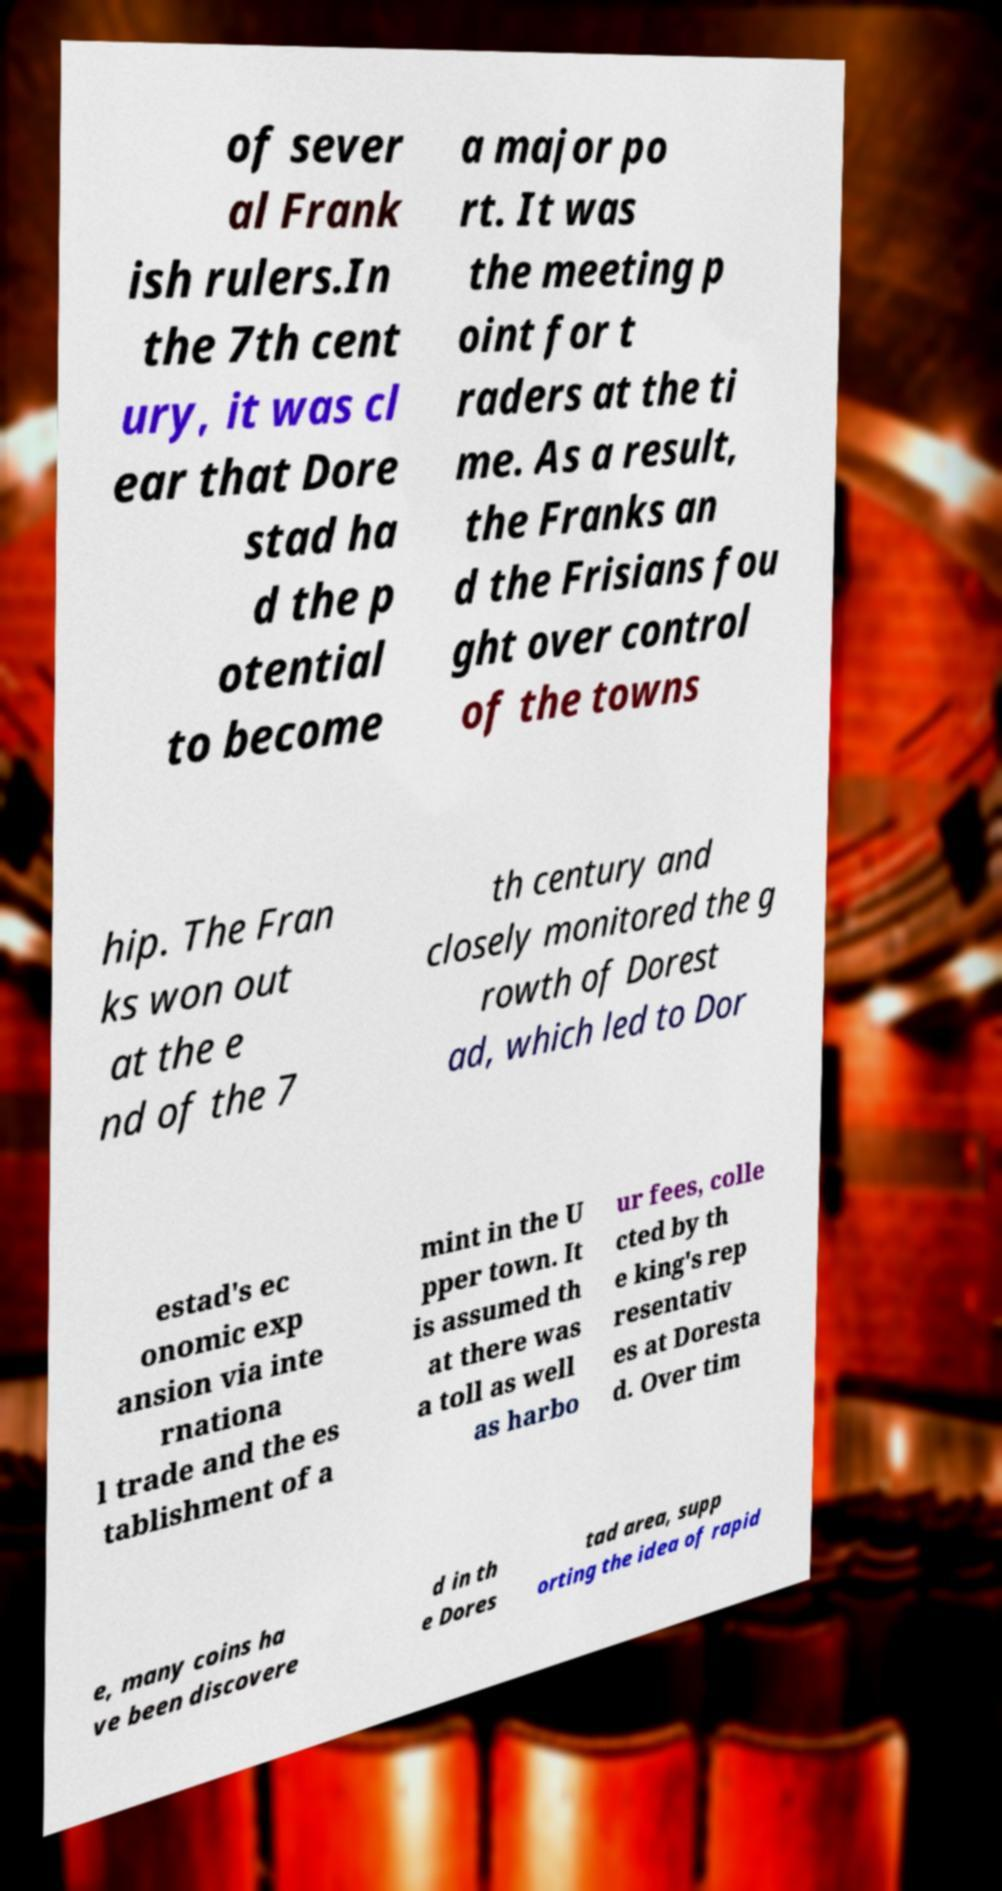Can you read and provide the text displayed in the image?This photo seems to have some interesting text. Can you extract and type it out for me? of sever al Frank ish rulers.In the 7th cent ury, it was cl ear that Dore stad ha d the p otential to become a major po rt. It was the meeting p oint for t raders at the ti me. As a result, the Franks an d the Frisians fou ght over control of the towns hip. The Fran ks won out at the e nd of the 7 th century and closely monitored the g rowth of Dorest ad, which led to Dor estad's ec onomic exp ansion via inte rnationa l trade and the es tablishment of a mint in the U pper town. It is assumed th at there was a toll as well as harbo ur fees, colle cted by th e king's rep resentativ es at Doresta d. Over tim e, many coins ha ve been discovere d in th e Dores tad area, supp orting the idea of rapid 